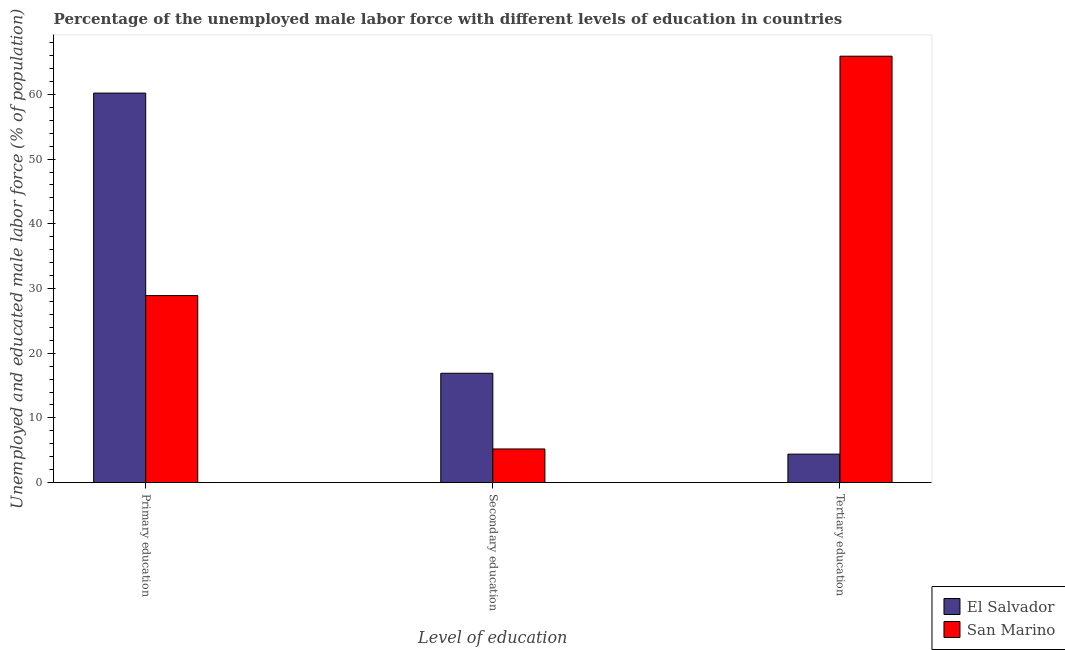How many different coloured bars are there?
Provide a succinct answer. 2. How many groups of bars are there?
Make the answer very short. 3. How many bars are there on the 1st tick from the left?
Give a very brief answer. 2. What is the label of the 1st group of bars from the left?
Provide a short and direct response. Primary education. What is the percentage of male labor force who received primary education in San Marino?
Your answer should be very brief. 28.9. Across all countries, what is the maximum percentage of male labor force who received tertiary education?
Give a very brief answer. 65.9. Across all countries, what is the minimum percentage of male labor force who received tertiary education?
Keep it short and to the point. 4.4. In which country was the percentage of male labor force who received secondary education maximum?
Your answer should be compact. El Salvador. In which country was the percentage of male labor force who received primary education minimum?
Give a very brief answer. San Marino. What is the total percentage of male labor force who received primary education in the graph?
Make the answer very short. 89.1. What is the difference between the percentage of male labor force who received secondary education in San Marino and that in El Salvador?
Offer a very short reply. -11.7. What is the difference between the percentage of male labor force who received secondary education in San Marino and the percentage of male labor force who received tertiary education in El Salvador?
Ensure brevity in your answer.  0.8. What is the average percentage of male labor force who received tertiary education per country?
Provide a short and direct response. 35.15. What is the difference between the percentage of male labor force who received tertiary education and percentage of male labor force who received primary education in El Salvador?
Provide a short and direct response. -55.8. In how many countries, is the percentage of male labor force who received tertiary education greater than 54 %?
Offer a very short reply. 1. What is the ratio of the percentage of male labor force who received primary education in San Marino to that in El Salvador?
Give a very brief answer. 0.48. Is the difference between the percentage of male labor force who received primary education in San Marino and El Salvador greater than the difference between the percentage of male labor force who received tertiary education in San Marino and El Salvador?
Ensure brevity in your answer.  No. What is the difference between the highest and the second highest percentage of male labor force who received secondary education?
Offer a terse response. 11.7. What is the difference between the highest and the lowest percentage of male labor force who received tertiary education?
Provide a succinct answer. 61.5. In how many countries, is the percentage of male labor force who received tertiary education greater than the average percentage of male labor force who received tertiary education taken over all countries?
Offer a terse response. 1. Is the sum of the percentage of male labor force who received primary education in El Salvador and San Marino greater than the maximum percentage of male labor force who received secondary education across all countries?
Make the answer very short. Yes. What does the 1st bar from the left in Primary education represents?
Provide a succinct answer. El Salvador. What does the 2nd bar from the right in Secondary education represents?
Offer a very short reply. El Salvador. Is it the case that in every country, the sum of the percentage of male labor force who received primary education and percentage of male labor force who received secondary education is greater than the percentage of male labor force who received tertiary education?
Give a very brief answer. No. How many bars are there?
Your answer should be compact. 6. Are all the bars in the graph horizontal?
Your answer should be compact. No. What is the difference between two consecutive major ticks on the Y-axis?
Offer a very short reply. 10. Does the graph contain any zero values?
Provide a succinct answer. No. Does the graph contain grids?
Your response must be concise. No. Where does the legend appear in the graph?
Offer a very short reply. Bottom right. What is the title of the graph?
Ensure brevity in your answer.  Percentage of the unemployed male labor force with different levels of education in countries. Does "St. Vincent and the Grenadines" appear as one of the legend labels in the graph?
Give a very brief answer. No. What is the label or title of the X-axis?
Keep it short and to the point. Level of education. What is the label or title of the Y-axis?
Provide a succinct answer. Unemployed and educated male labor force (% of population). What is the Unemployed and educated male labor force (% of population) in El Salvador in Primary education?
Your response must be concise. 60.2. What is the Unemployed and educated male labor force (% of population) in San Marino in Primary education?
Give a very brief answer. 28.9. What is the Unemployed and educated male labor force (% of population) of El Salvador in Secondary education?
Your answer should be very brief. 16.9. What is the Unemployed and educated male labor force (% of population) of San Marino in Secondary education?
Offer a very short reply. 5.2. What is the Unemployed and educated male labor force (% of population) in El Salvador in Tertiary education?
Provide a short and direct response. 4.4. What is the Unemployed and educated male labor force (% of population) in San Marino in Tertiary education?
Provide a short and direct response. 65.9. Across all Level of education, what is the maximum Unemployed and educated male labor force (% of population) of El Salvador?
Make the answer very short. 60.2. Across all Level of education, what is the maximum Unemployed and educated male labor force (% of population) in San Marino?
Make the answer very short. 65.9. Across all Level of education, what is the minimum Unemployed and educated male labor force (% of population) of El Salvador?
Ensure brevity in your answer.  4.4. Across all Level of education, what is the minimum Unemployed and educated male labor force (% of population) of San Marino?
Offer a terse response. 5.2. What is the total Unemployed and educated male labor force (% of population) in El Salvador in the graph?
Make the answer very short. 81.5. What is the difference between the Unemployed and educated male labor force (% of population) in El Salvador in Primary education and that in Secondary education?
Your response must be concise. 43.3. What is the difference between the Unemployed and educated male labor force (% of population) in San Marino in Primary education and that in Secondary education?
Your answer should be compact. 23.7. What is the difference between the Unemployed and educated male labor force (% of population) of El Salvador in Primary education and that in Tertiary education?
Provide a succinct answer. 55.8. What is the difference between the Unemployed and educated male labor force (% of population) of San Marino in Primary education and that in Tertiary education?
Provide a succinct answer. -37. What is the difference between the Unemployed and educated male labor force (% of population) in El Salvador in Secondary education and that in Tertiary education?
Your answer should be compact. 12.5. What is the difference between the Unemployed and educated male labor force (% of population) in San Marino in Secondary education and that in Tertiary education?
Provide a short and direct response. -60.7. What is the difference between the Unemployed and educated male labor force (% of population) in El Salvador in Primary education and the Unemployed and educated male labor force (% of population) in San Marino in Secondary education?
Ensure brevity in your answer.  55. What is the difference between the Unemployed and educated male labor force (% of population) of El Salvador in Secondary education and the Unemployed and educated male labor force (% of population) of San Marino in Tertiary education?
Provide a succinct answer. -49. What is the average Unemployed and educated male labor force (% of population) of El Salvador per Level of education?
Provide a short and direct response. 27.17. What is the average Unemployed and educated male labor force (% of population) in San Marino per Level of education?
Give a very brief answer. 33.33. What is the difference between the Unemployed and educated male labor force (% of population) in El Salvador and Unemployed and educated male labor force (% of population) in San Marino in Primary education?
Make the answer very short. 31.3. What is the difference between the Unemployed and educated male labor force (% of population) of El Salvador and Unemployed and educated male labor force (% of population) of San Marino in Secondary education?
Offer a very short reply. 11.7. What is the difference between the Unemployed and educated male labor force (% of population) in El Salvador and Unemployed and educated male labor force (% of population) in San Marino in Tertiary education?
Give a very brief answer. -61.5. What is the ratio of the Unemployed and educated male labor force (% of population) of El Salvador in Primary education to that in Secondary education?
Keep it short and to the point. 3.56. What is the ratio of the Unemployed and educated male labor force (% of population) of San Marino in Primary education to that in Secondary education?
Your answer should be compact. 5.56. What is the ratio of the Unemployed and educated male labor force (% of population) in El Salvador in Primary education to that in Tertiary education?
Provide a succinct answer. 13.68. What is the ratio of the Unemployed and educated male labor force (% of population) in San Marino in Primary education to that in Tertiary education?
Make the answer very short. 0.44. What is the ratio of the Unemployed and educated male labor force (% of population) of El Salvador in Secondary education to that in Tertiary education?
Give a very brief answer. 3.84. What is the ratio of the Unemployed and educated male labor force (% of population) of San Marino in Secondary education to that in Tertiary education?
Your answer should be compact. 0.08. What is the difference between the highest and the second highest Unemployed and educated male labor force (% of population) in El Salvador?
Offer a terse response. 43.3. What is the difference between the highest and the second highest Unemployed and educated male labor force (% of population) of San Marino?
Your answer should be very brief. 37. What is the difference between the highest and the lowest Unemployed and educated male labor force (% of population) of El Salvador?
Make the answer very short. 55.8. What is the difference between the highest and the lowest Unemployed and educated male labor force (% of population) in San Marino?
Provide a short and direct response. 60.7. 